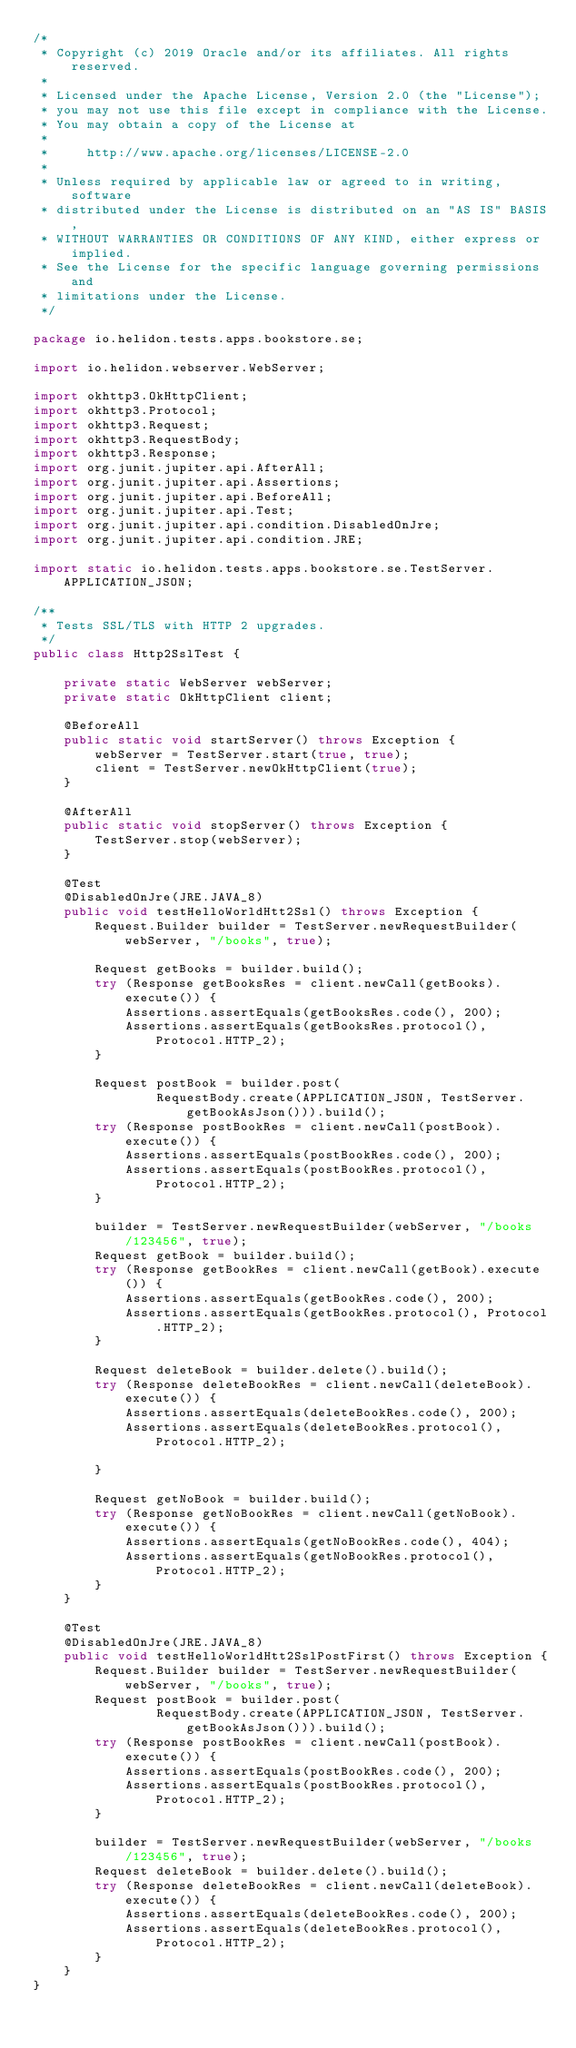Convert code to text. <code><loc_0><loc_0><loc_500><loc_500><_Java_>/*
 * Copyright (c) 2019 Oracle and/or its affiliates. All rights reserved.
 *
 * Licensed under the Apache License, Version 2.0 (the "License");
 * you may not use this file except in compliance with the License.
 * You may obtain a copy of the License at
 *
 *     http://www.apache.org/licenses/LICENSE-2.0
 *
 * Unless required by applicable law or agreed to in writing, software
 * distributed under the License is distributed on an "AS IS" BASIS,
 * WITHOUT WARRANTIES OR CONDITIONS OF ANY KIND, either express or implied.
 * See the License for the specific language governing permissions and
 * limitations under the License.
 */

package io.helidon.tests.apps.bookstore.se;

import io.helidon.webserver.WebServer;

import okhttp3.OkHttpClient;
import okhttp3.Protocol;
import okhttp3.Request;
import okhttp3.RequestBody;
import okhttp3.Response;
import org.junit.jupiter.api.AfterAll;
import org.junit.jupiter.api.Assertions;
import org.junit.jupiter.api.BeforeAll;
import org.junit.jupiter.api.Test;
import org.junit.jupiter.api.condition.DisabledOnJre;
import org.junit.jupiter.api.condition.JRE;

import static io.helidon.tests.apps.bookstore.se.TestServer.APPLICATION_JSON;

/**
 * Tests SSL/TLS with HTTP 2 upgrades.
 */
public class Http2SslTest {

    private static WebServer webServer;
    private static OkHttpClient client;

    @BeforeAll
    public static void startServer() throws Exception {
        webServer = TestServer.start(true, true);
        client = TestServer.newOkHttpClient(true);
    }

    @AfterAll
    public static void stopServer() throws Exception {
        TestServer.stop(webServer);
    }

    @Test
    @DisabledOnJre(JRE.JAVA_8)
    public void testHelloWorldHtt2Ssl() throws Exception {
        Request.Builder builder = TestServer.newRequestBuilder(webServer, "/books", true);

        Request getBooks = builder.build();
        try (Response getBooksRes = client.newCall(getBooks).execute()) {
            Assertions.assertEquals(getBooksRes.code(), 200);
            Assertions.assertEquals(getBooksRes.protocol(), Protocol.HTTP_2);
        }

        Request postBook = builder.post(
                RequestBody.create(APPLICATION_JSON, TestServer.getBookAsJson())).build();
        try (Response postBookRes = client.newCall(postBook).execute()) {
            Assertions.assertEquals(postBookRes.code(), 200);
            Assertions.assertEquals(postBookRes.protocol(), Protocol.HTTP_2);
        }

        builder = TestServer.newRequestBuilder(webServer, "/books/123456", true);
        Request getBook = builder.build();
        try (Response getBookRes = client.newCall(getBook).execute()) {
            Assertions.assertEquals(getBookRes.code(), 200);
            Assertions.assertEquals(getBookRes.protocol(), Protocol.HTTP_2);
        }

        Request deleteBook = builder.delete().build();
        try (Response deleteBookRes = client.newCall(deleteBook).execute()) {
            Assertions.assertEquals(deleteBookRes.code(), 200);
            Assertions.assertEquals(deleteBookRes.protocol(), Protocol.HTTP_2);

        }

        Request getNoBook = builder.build();
        try (Response getNoBookRes = client.newCall(getNoBook).execute()) {
            Assertions.assertEquals(getNoBookRes.code(), 404);
            Assertions.assertEquals(getNoBookRes.protocol(), Protocol.HTTP_2);
        }
    }

    @Test
    @DisabledOnJre(JRE.JAVA_8)
    public void testHelloWorldHtt2SslPostFirst() throws Exception {
        Request.Builder builder = TestServer.newRequestBuilder(webServer, "/books", true);
        Request postBook = builder.post(
                RequestBody.create(APPLICATION_JSON, TestServer.getBookAsJson())).build();
        try (Response postBookRes = client.newCall(postBook).execute()) {
            Assertions.assertEquals(postBookRes.code(), 200);
            Assertions.assertEquals(postBookRes.protocol(), Protocol.HTTP_2);
        }

        builder = TestServer.newRequestBuilder(webServer, "/books/123456", true);
        Request deleteBook = builder.delete().build();
        try (Response deleteBookRes = client.newCall(deleteBook).execute()) {
            Assertions.assertEquals(deleteBookRes.code(), 200);
            Assertions.assertEquals(deleteBookRes.protocol(), Protocol.HTTP_2);
        }
    }
}
</code> 